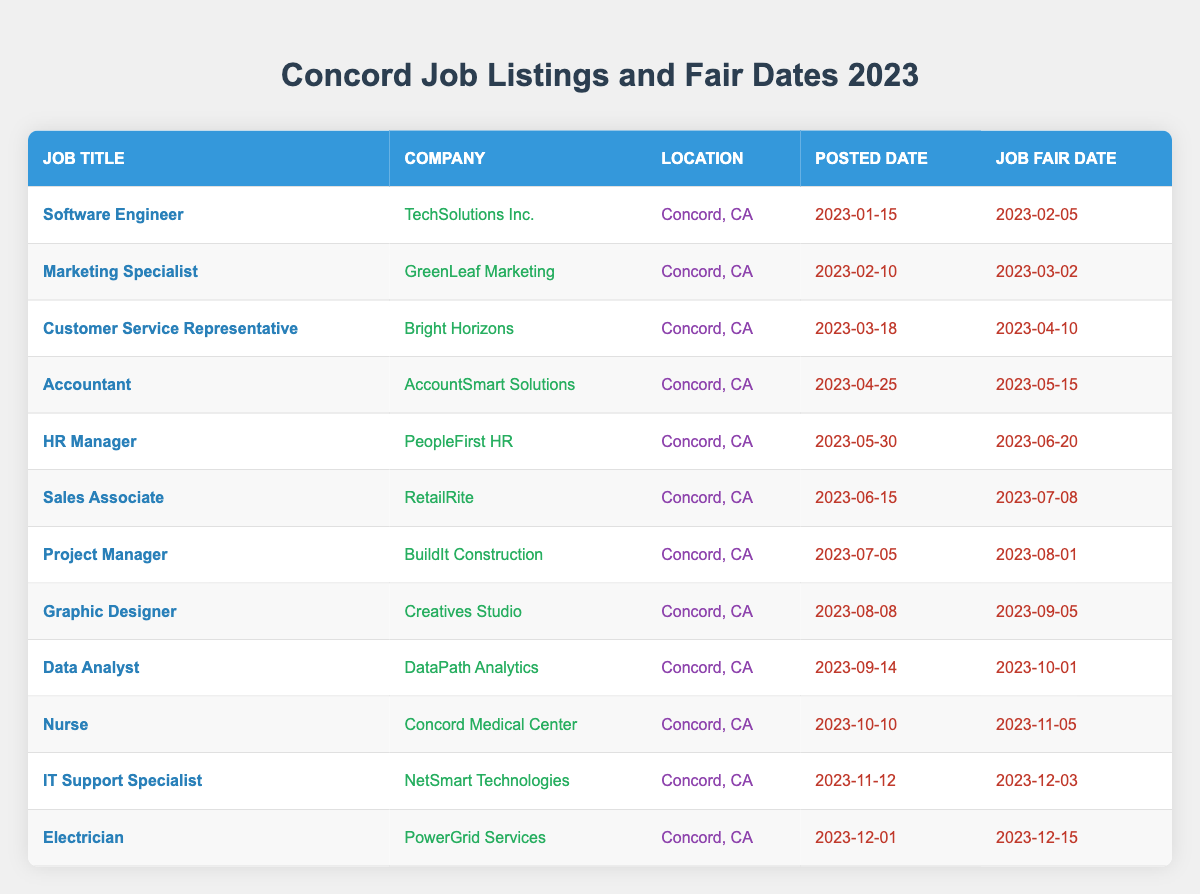What is the job title posted earliest in 2023? The job listings start with the Software Engineer position, which was posted on January 15, 2023. This date is earlier than all the other job postings in the table.
Answer: Software Engineer Which company is hiring for the Data Analyst position? The Data Analyst position is offered by DataPath Analytics, as shown in the company column for the corresponding job title in the table.
Answer: DataPath Analytics How many job listings have job fairs occurring in November 2023? There are two job listings with job fairs in November: one is for the Nurse position on November 5, and the other is for the IT Support Specialist on December 3, but the question specifies November. So, we count only the Nurse job fair.
Answer: 1 What is the average time between job posting date and job fair date across all listings? To find the average time, we need to calculate the difference between the job posting date and job fair date for each job listing, sum those differences, and then divide by the total number of job listings (12). For instance, the Software Engineer has a difference of 21 days, Marketing Specialist has 20 days, and so on. If we calculate all the differences and average them out, we find a total of 163 days for 12 postings, resulting in an average of approximately 13.58 days.
Answer: 13.58 days Did any job listing have the same company name as the job title? After checking the job titles against their corresponding companies in the table, it's clear that none of the job listings share the same name for both the job title and the company. Each title and company name are distinct without duplicates.
Answer: No Which job posting has the latest job fair date? The latest job fair date is for the Electrician position, which is scheduled for December 15, 2023. Checking the job fair dates systematically from the table confirms this.
Answer: Electrician How many jobs have been listed for the role of Specialist? Only two job listings fall under the "Specialist" role: Marketing Specialist and IT Support Specialist. The search for the word "Specialist" in the job titles shows these two matches.
Answer: 2 Is the HR Manager job fair date after the job fair date of the Accountant position? The job fair date for HR Manager is June 20, 2023, while that for Accountant is May 15, 2023. Comparing these two dates shows that June comes after May, confirming that the HR Manager's fair is indeed after the Accountant's.
Answer: Yes 